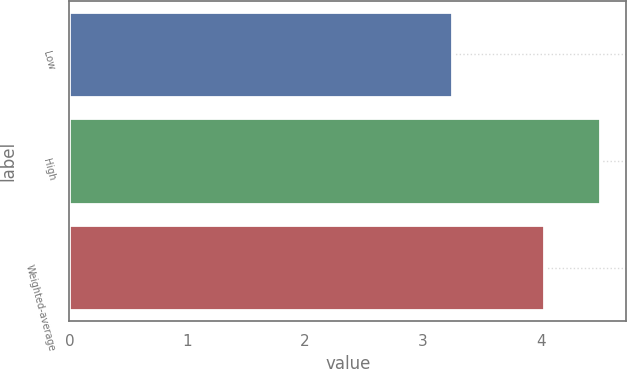Convert chart to OTSL. <chart><loc_0><loc_0><loc_500><loc_500><bar_chart><fcel>Low<fcel>High<fcel>Weighted-average<nl><fcel>3.25<fcel>4.5<fcel>4.03<nl></chart> 